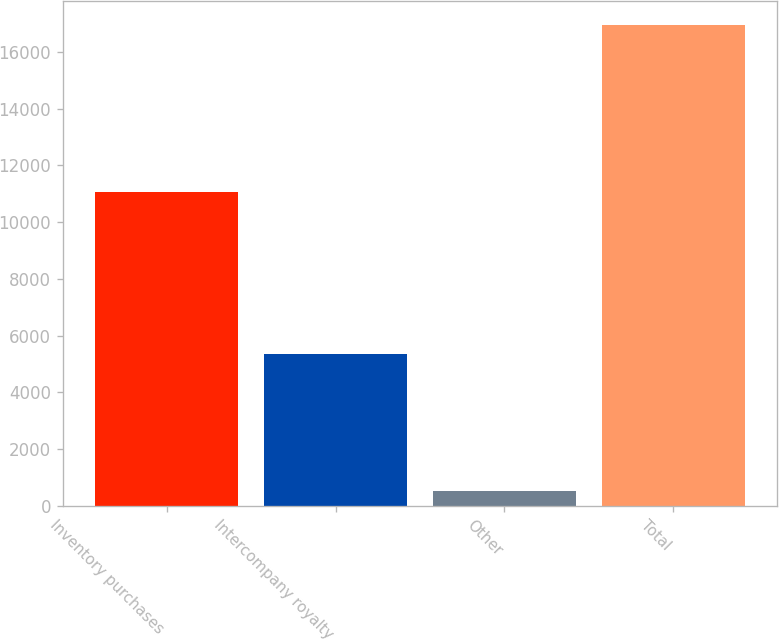Convert chart to OTSL. <chart><loc_0><loc_0><loc_500><loc_500><bar_chart><fcel>Inventory purchases<fcel>Intercompany royalty<fcel>Other<fcel>Total<nl><fcel>11074<fcel>5344<fcel>533<fcel>16951<nl></chart> 